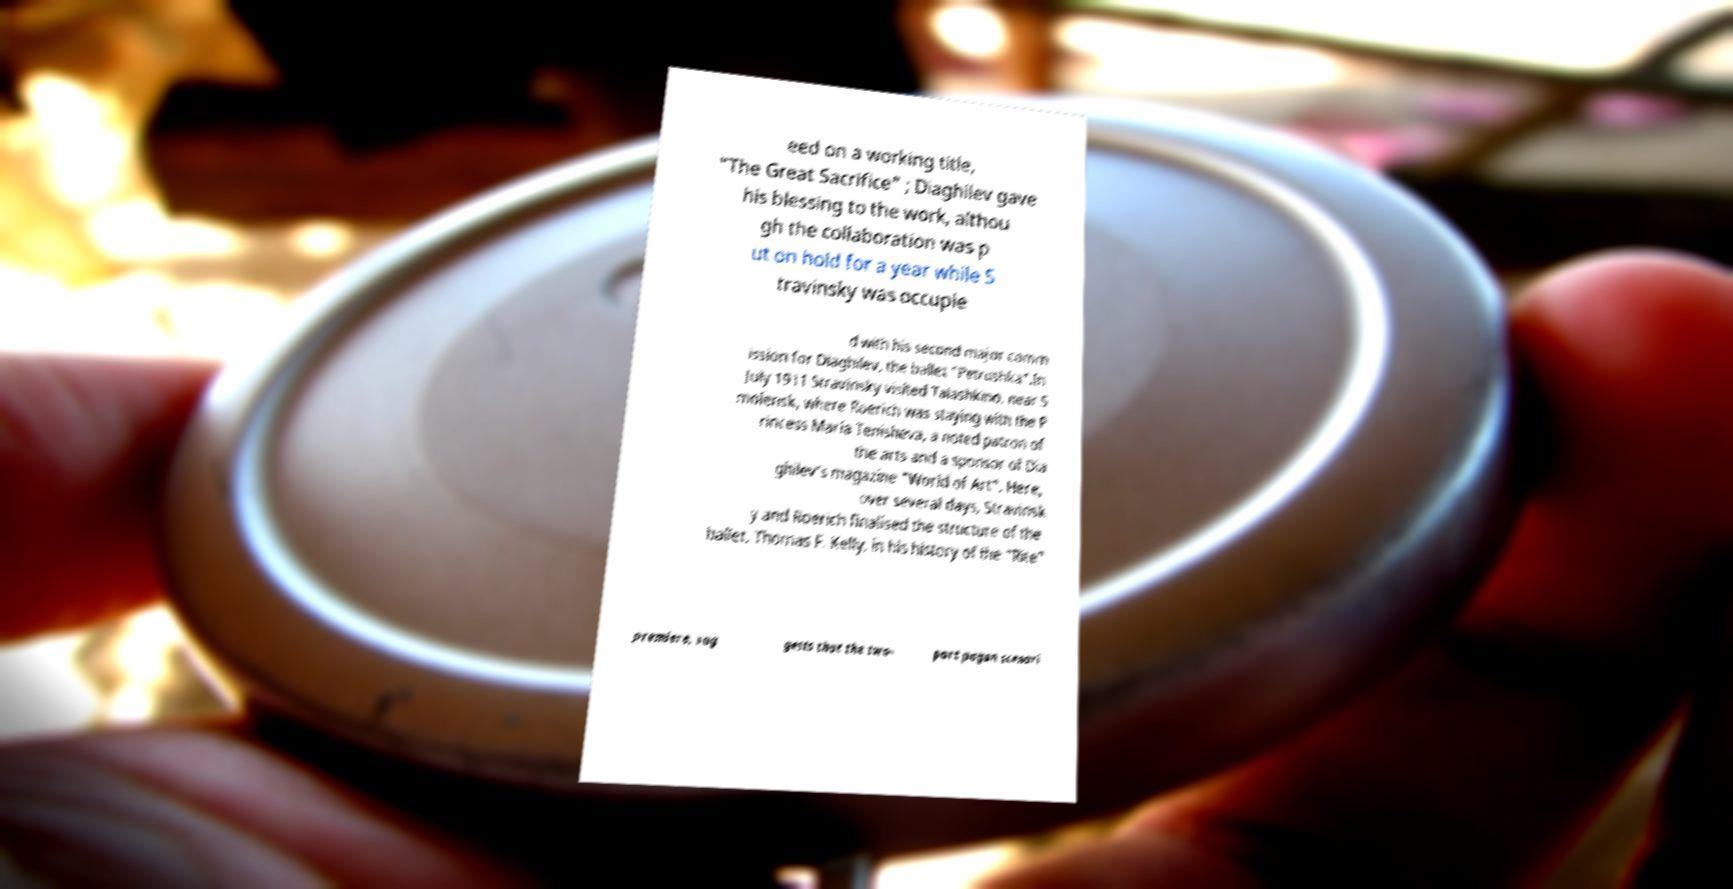I need the written content from this picture converted into text. Can you do that? eed on a working title, "The Great Sacrifice" ; Diaghilev gave his blessing to the work, althou gh the collaboration was p ut on hold for a year while S travinsky was occupie d with his second major comm ission for Diaghilev, the ballet "Petrushka".In July 1911 Stravinsky visited Talashkino, near S molensk, where Roerich was staying with the P rincess Maria Tenisheva, a noted patron of the arts and a sponsor of Dia ghilev's magazine "World of Art". Here, over several days, Stravinsk y and Roerich finalised the structure of the ballet. Thomas F. Kelly, in his history of the "Rite" premiere, sug gests that the two- part pagan scenari 